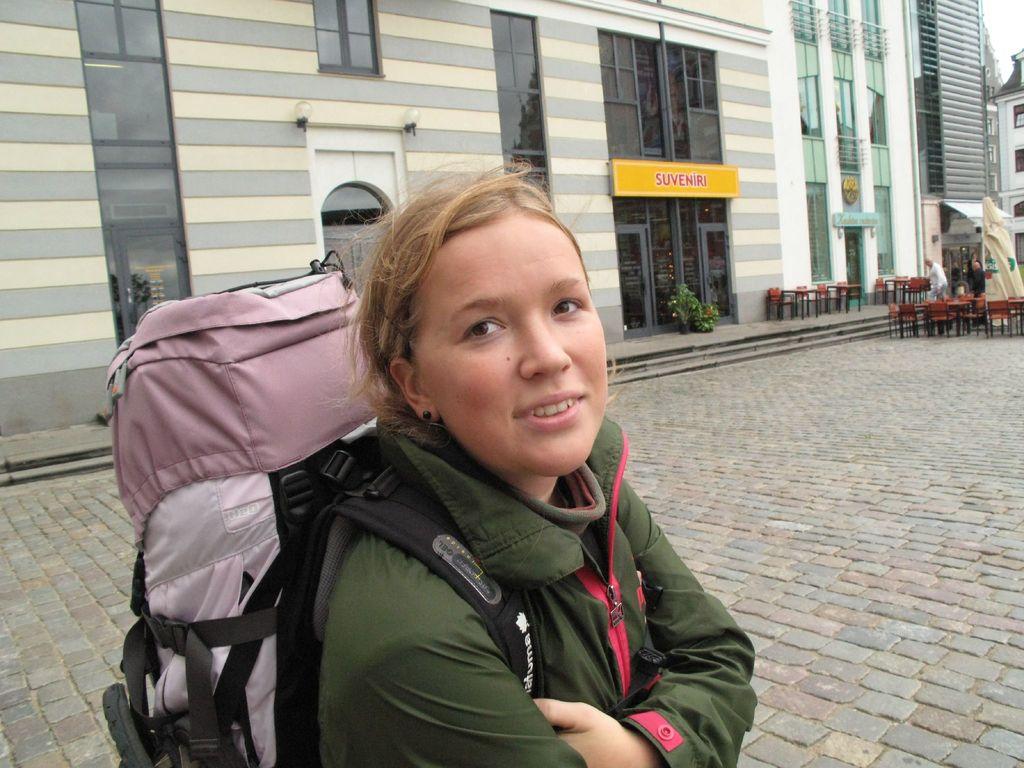What is on the yellow awning?
Your answer should be very brief. Suveniri. 